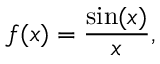Convert formula to latex. <formula><loc_0><loc_0><loc_500><loc_500>f ( x ) = { \frac { \sin ( x ) } { x } } ,</formula> 